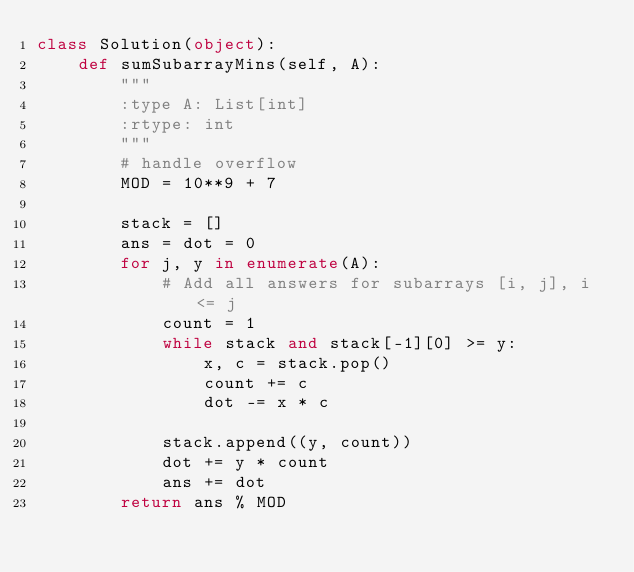<code> <loc_0><loc_0><loc_500><loc_500><_Python_>class Solution(object):
    def sumSubarrayMins(self, A):
        """
        :type A: List[int]
        :rtype: int
        """
        # handle overflow
        MOD = 10**9 + 7

        stack = []
        ans = dot = 0
        for j, y in enumerate(A):
            # Add all answers for subarrays [i, j], i <= j
            count = 1
            while stack and stack[-1][0] >= y:
                x, c = stack.pop()
                count += c
                dot -= x * c

            stack.append((y, count))
            dot += y * count
            ans += dot
        return ans % MOD</code> 